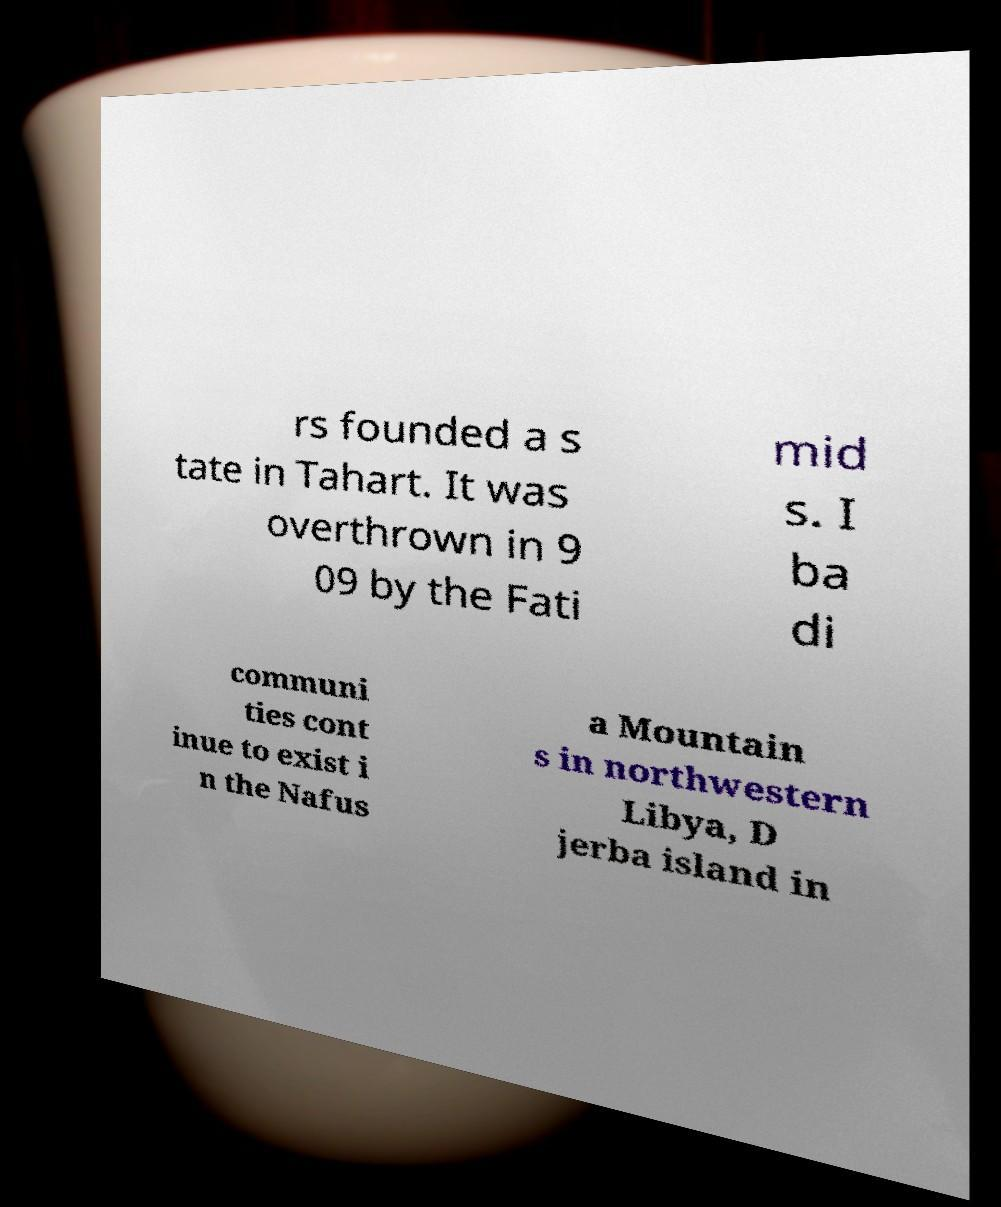Please identify and transcribe the text found in this image. rs founded a s tate in Tahart. It was overthrown in 9 09 by the Fati mid s. I ba di communi ties cont inue to exist i n the Nafus a Mountain s in northwestern Libya, D jerba island in 